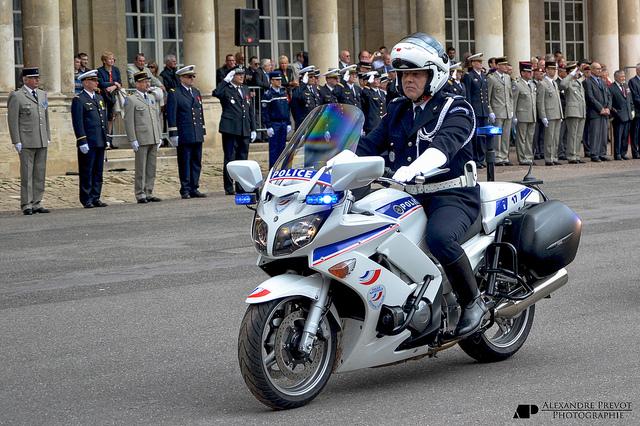What kind of service man is riding the motorcycle?
Write a very short answer. Police. What is the man riding?
Quick response, please. Motorcycle. What are some of the spectators doing with their hands?
Keep it brief. Saluting. 